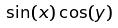Convert formula to latex. <formula><loc_0><loc_0><loc_500><loc_500>\sin ( x ) \cos ( y )</formula> 